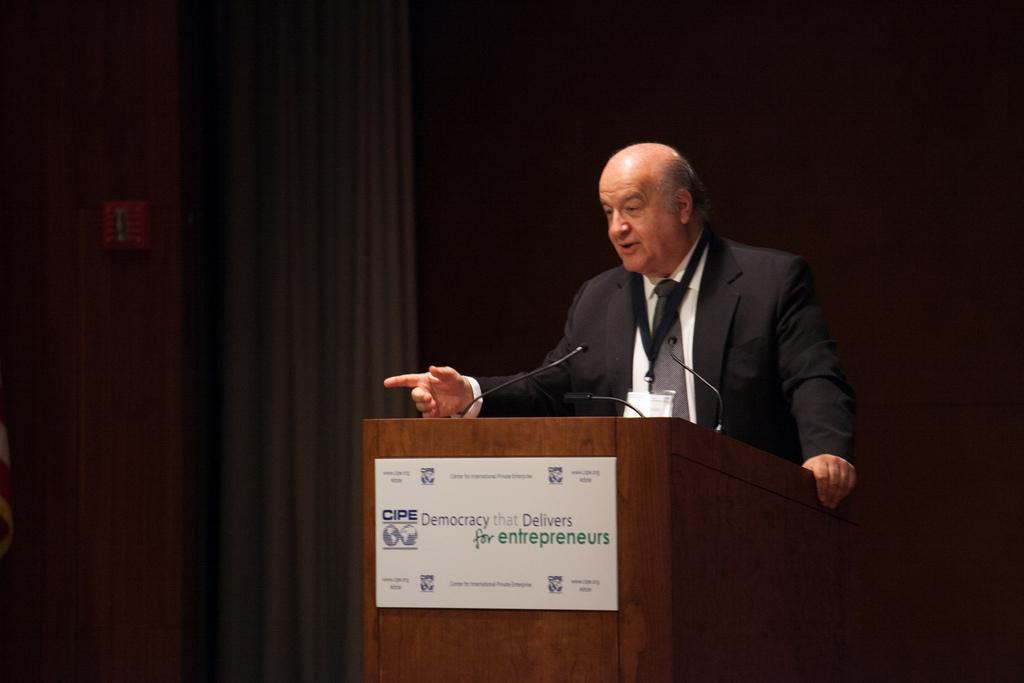What is the man in the image doing near the podium? The man is standing near a podium in the image. What is the board used for in the image? The purpose of the board in the image is not specified, but it could be used for displaying information or as a visual aid. How many microphones are visible in the image? There are microphones (mikes) in the image. What can be seen in the background of the image? There is a wall and other objects visible in the background of the image. What color is the balloon that the man is holding in the image? There is no balloon present in the image; the man is standing near a podium without any visible balloons. 